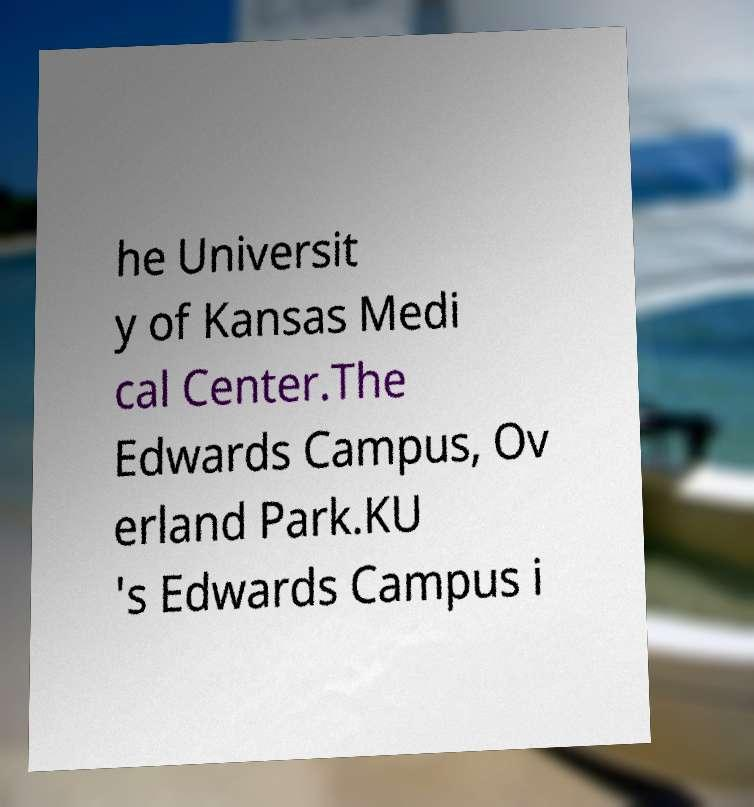Could you assist in decoding the text presented in this image and type it out clearly? he Universit y of Kansas Medi cal Center.The Edwards Campus, Ov erland Park.KU 's Edwards Campus i 